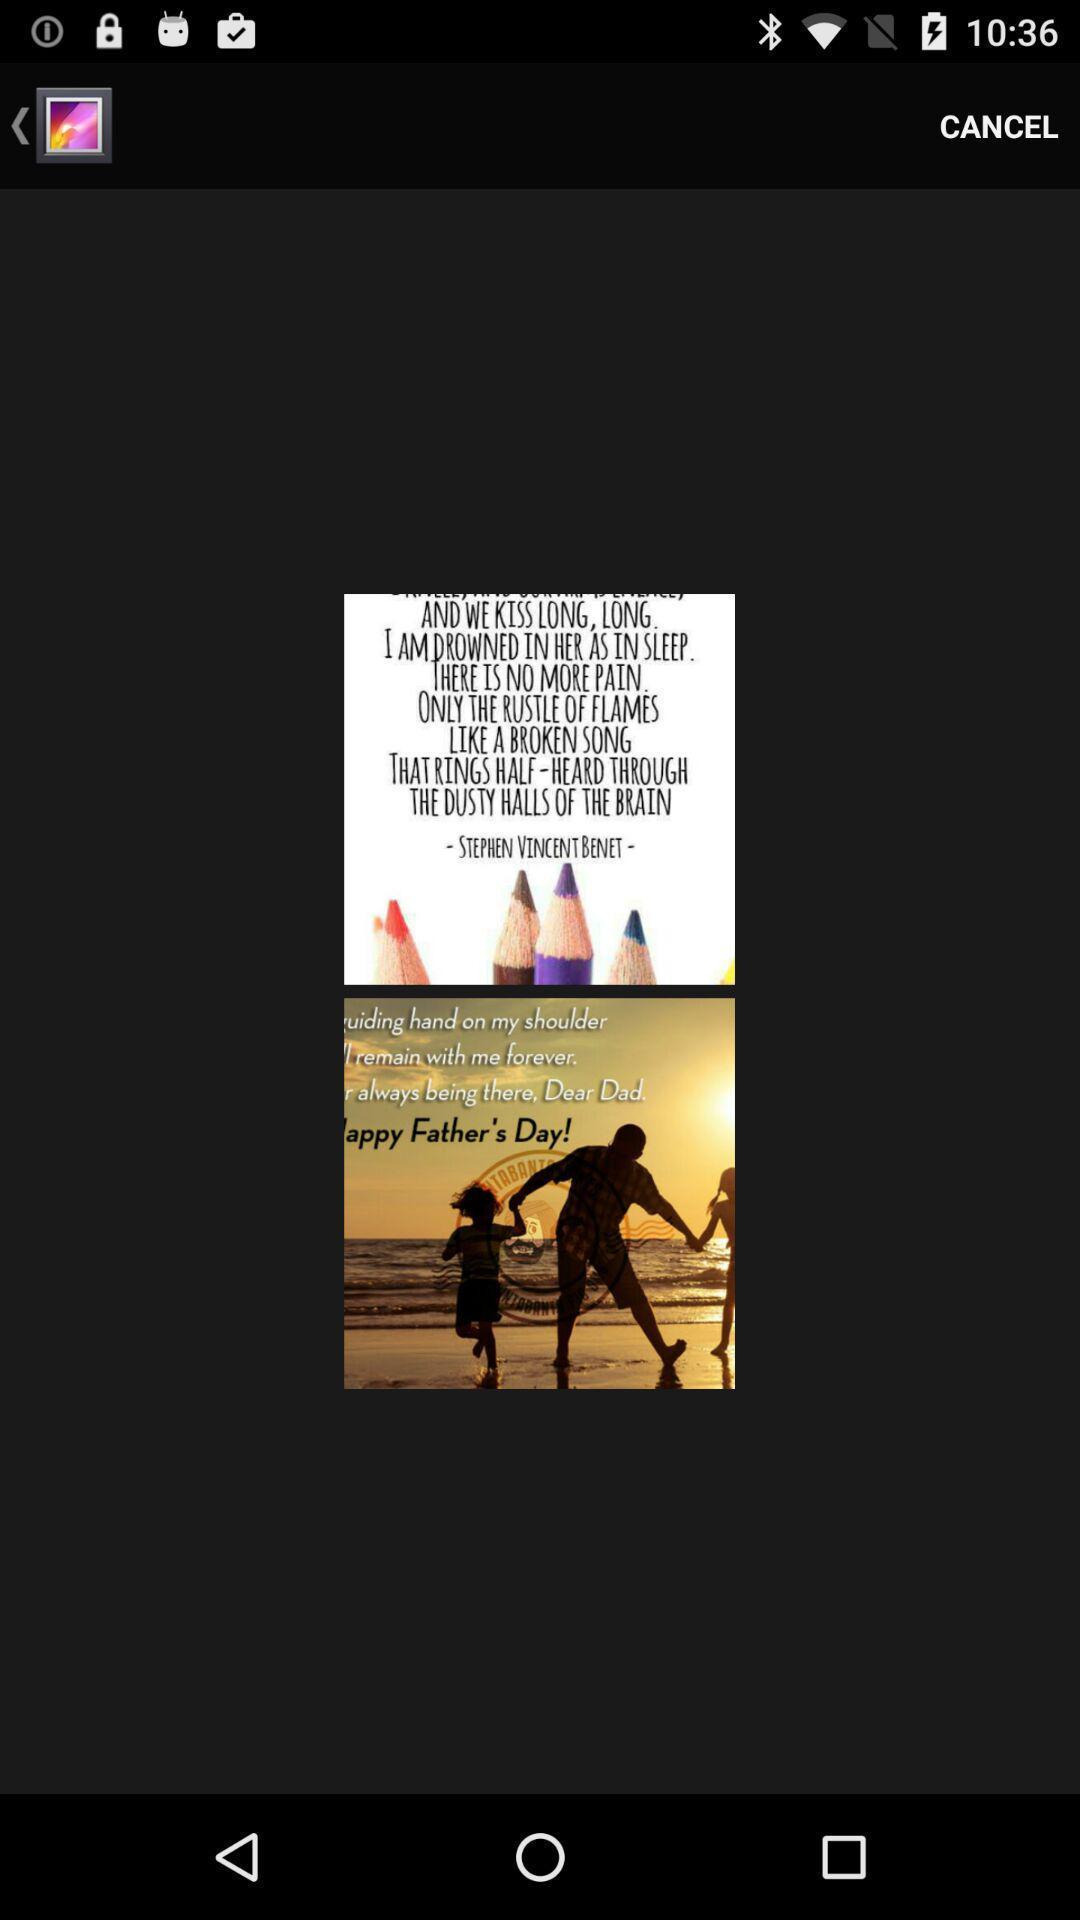Describe this image in words. Screen displaying two images in a page. 